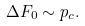Convert formula to latex. <formula><loc_0><loc_0><loc_500><loc_500>\Delta F _ { 0 } \sim p _ { c } .</formula> 